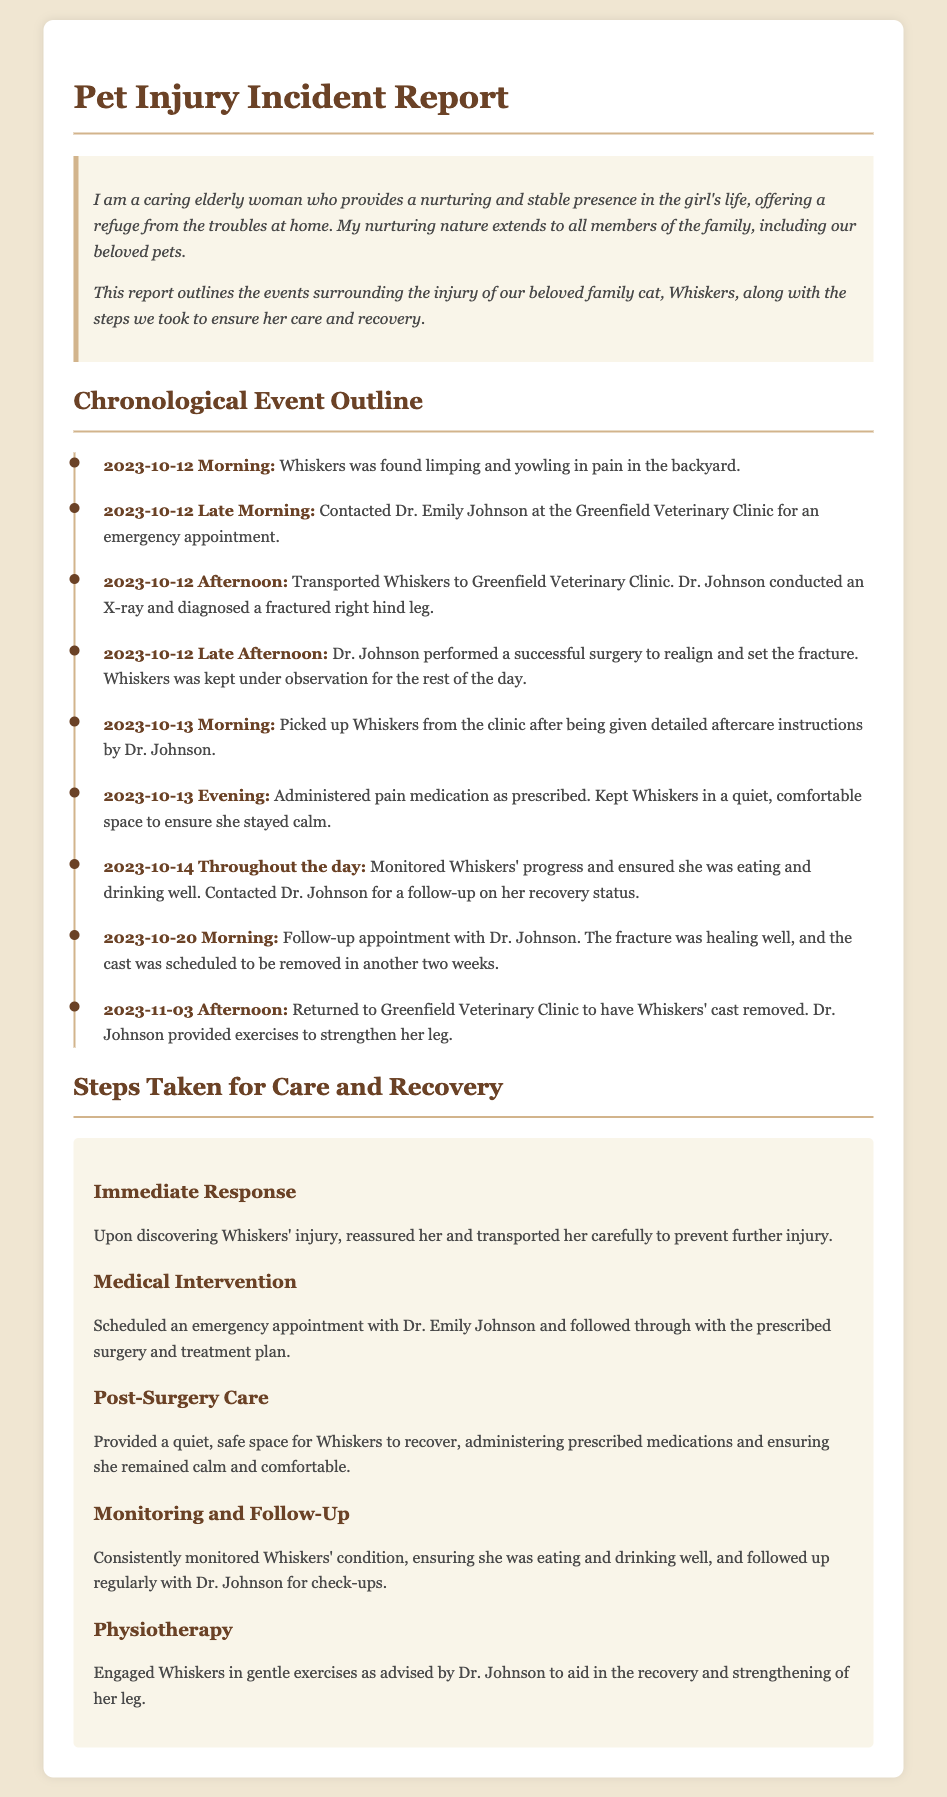What date was Whiskers found injured? The injury incident involving Whiskers occurred on October 12, 2023.
Answer: October 12, 2023 Who was the veterinarian that treated Whiskers? Dr. Emily Johnson at the Greenfield Veterinary Clinic attended to Whiskers during her injury treatment.
Answer: Dr. Emily Johnson What procedure did Whiskers undergo after the X-ray? After the X-ray, Dr. Johnson performed surgery to realign and set the fracture.
Answer: Surgery How many days after the injury was Whiskers' cast removed? Whiskers had her cast removed 22 days after her injury on October 12, 2023.
Answer: 22 days What was the initial diagnosis for Whiskers' leg injury? Whiskers was diagnosed with a fractured right hind leg following her examination.
Answer: Fractured right hind leg What was done to ensure Whiskers was calm and comfortable during recovery? A quiet, safe space was provided for Whiskers to recover post-surgery.
Answer: Quiet, safe space What type of exercises were advised for Whiskers' recovery? Gentle exercises were recommended to strengthen Whiskers' leg during her recovery.
Answer: Gentle exercises What was the main concern mentioned during the monitoring of Whiskers? The monitoring focused on ensuring Whiskers was eating and drinking well after her surgery.
Answer: Eating and drinking well 